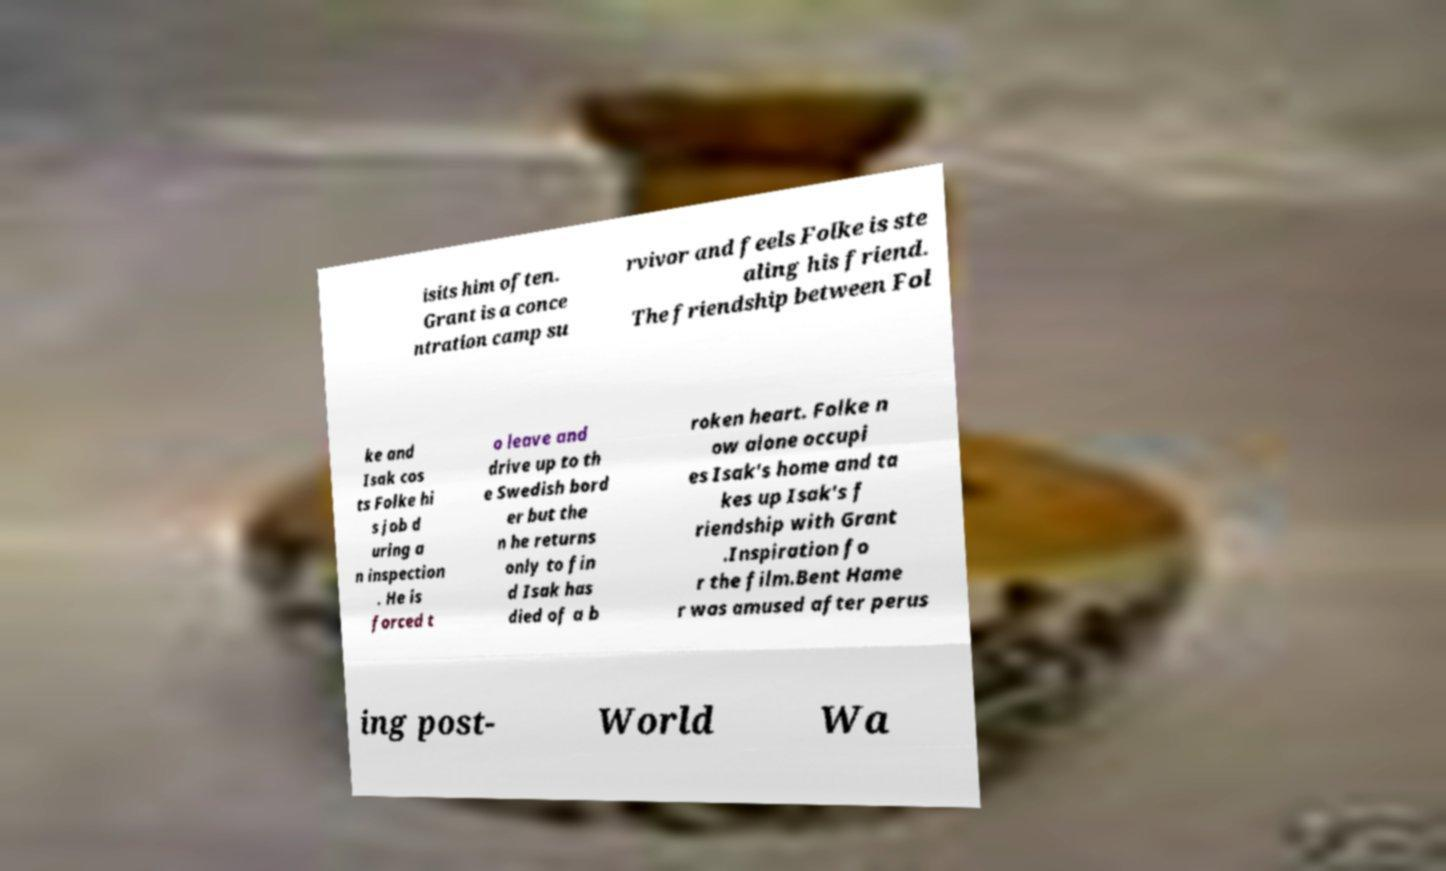Can you accurately transcribe the text from the provided image for me? isits him often. Grant is a conce ntration camp su rvivor and feels Folke is ste aling his friend. The friendship between Fol ke and Isak cos ts Folke hi s job d uring a n inspection . He is forced t o leave and drive up to th e Swedish bord er but the n he returns only to fin d Isak has died of a b roken heart. Folke n ow alone occupi es Isak's home and ta kes up Isak's f riendship with Grant .Inspiration fo r the film.Bent Hame r was amused after perus ing post- World Wa 